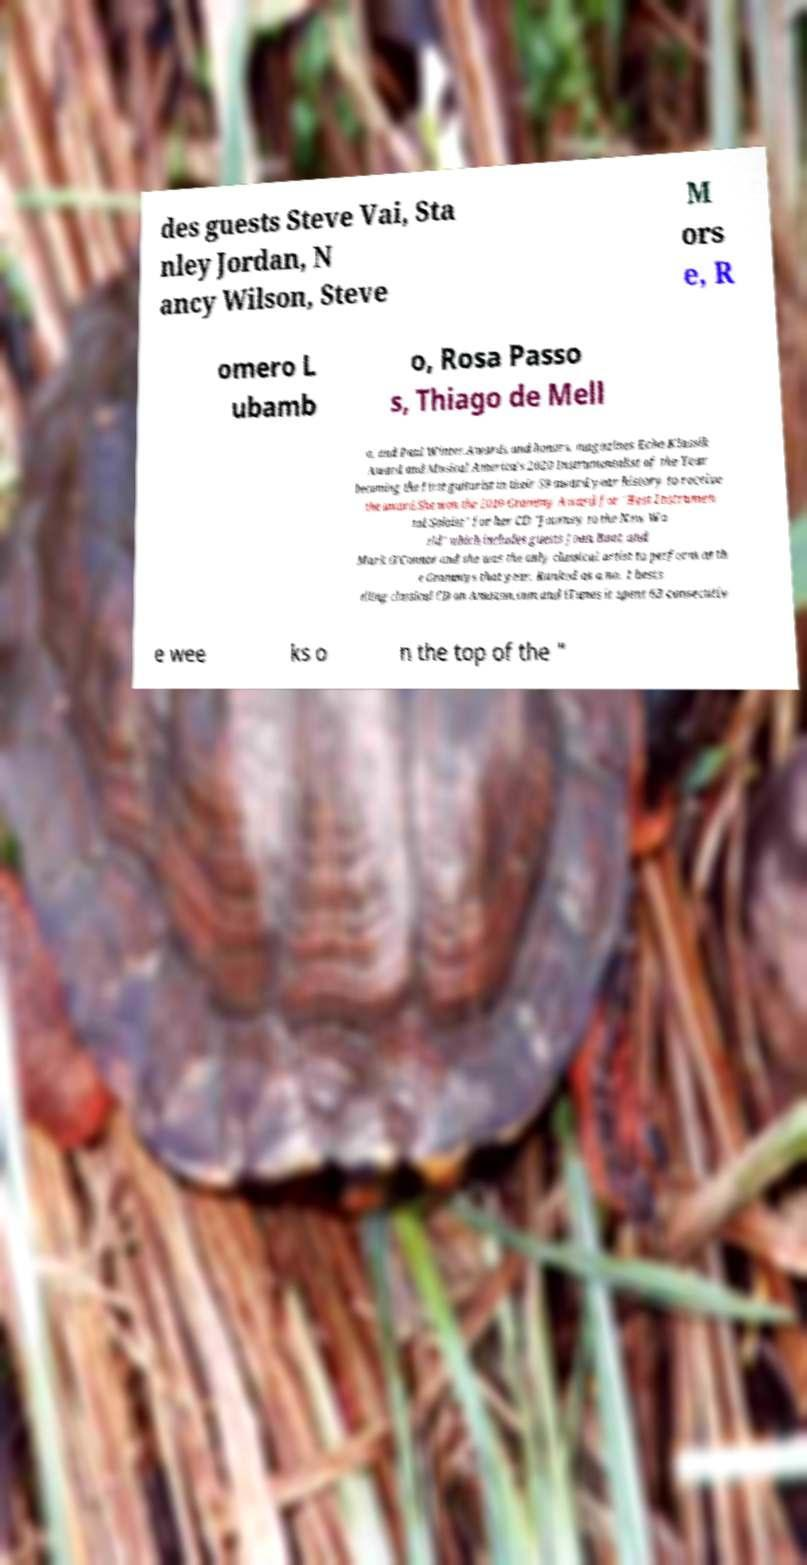Can you accurately transcribe the text from the provided image for me? des guests Steve Vai, Sta nley Jordan, N ancy Wilson, Steve M ors e, R omero L ubamb o, Rosa Passo s, Thiago de Mell o, and Paul Winter.Awards and honors. magazines Echo Klassik Award and Musical America’s 2020 Instrumentalist of the Year becoming the first guitarist in their 59 award year history to receive the award.She won the 2010 Grammy Award for "Best Instrumen tal Soloist" for her CD "Journey to the New Wo rld" which includes guests Joan Baez and Mark O'Connor and she was the only classical artist to perform at th e Grammys that year. Ranked as a no. 1 bests elling classical CD on Amazon.com and iTunes it spent 63 consecutiv e wee ks o n the top of the " 